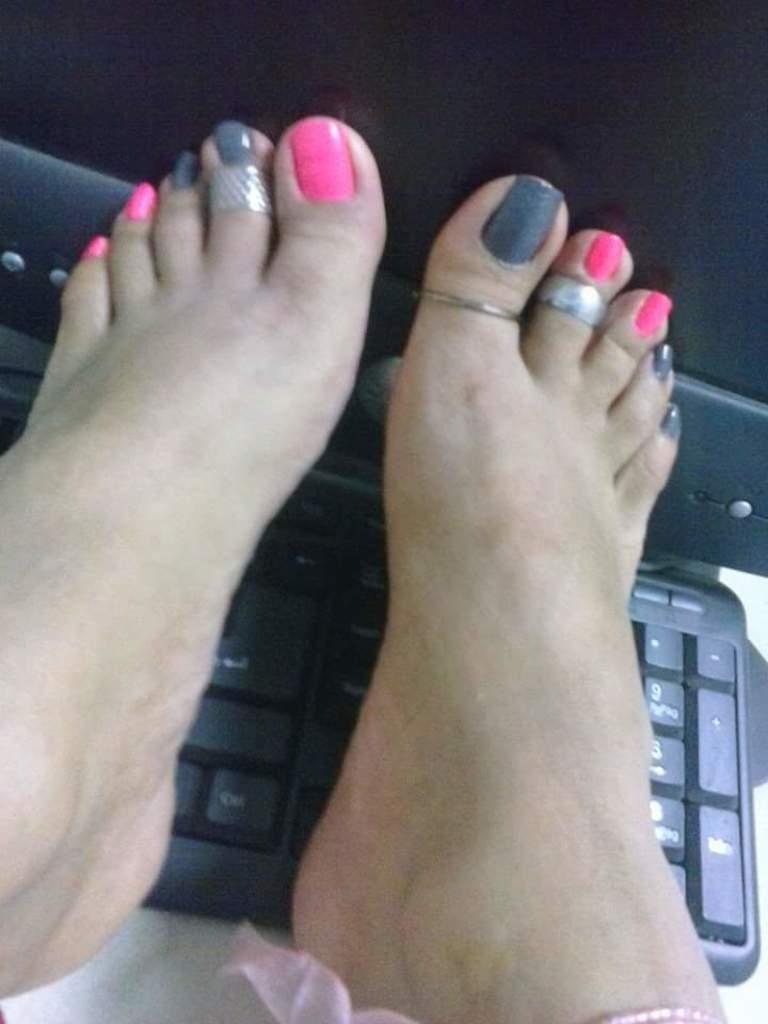Can you describe this image briefly? In this image we can see women feet on keyboard and monitor. 